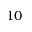<formula> <loc_0><loc_0><loc_500><loc_500>1 0</formula> 